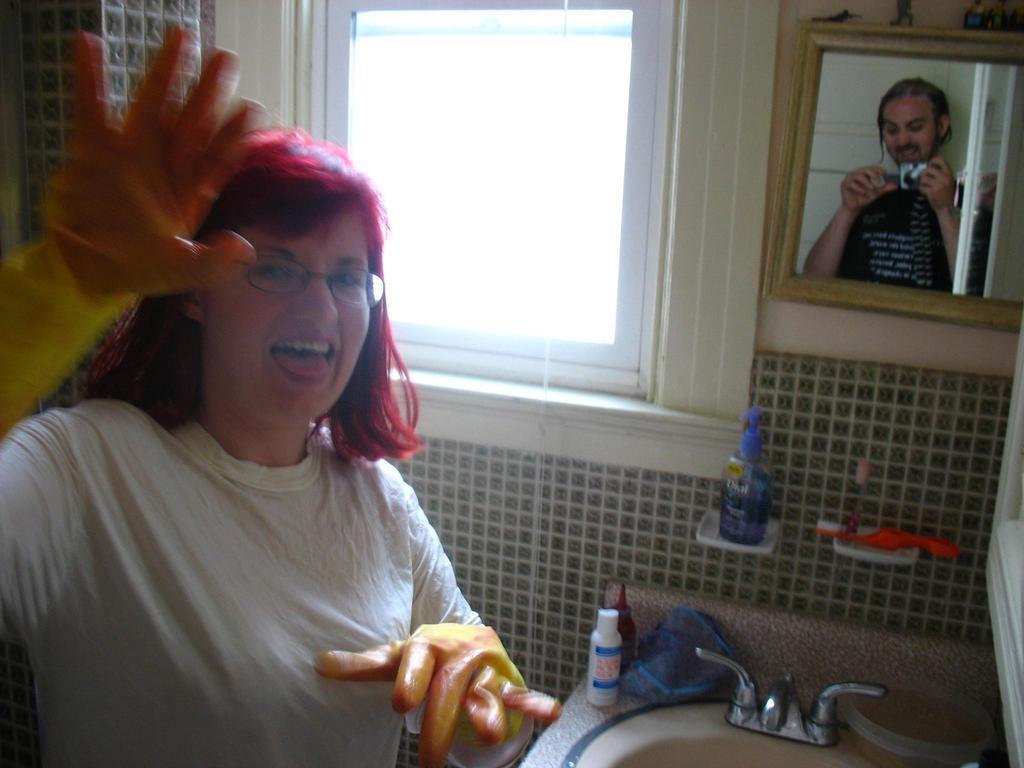Could you give a brief overview of what you see in this image? In this picture there is a woman with white t-shirt. On the right side of the image there is a wash basin and there are objects on the wash basin and there is a bottle and there is a brush on the stands and there is a mirror on the wall, on the mirror there is a reflection of a man. At the back there is a window and there is a wall. 